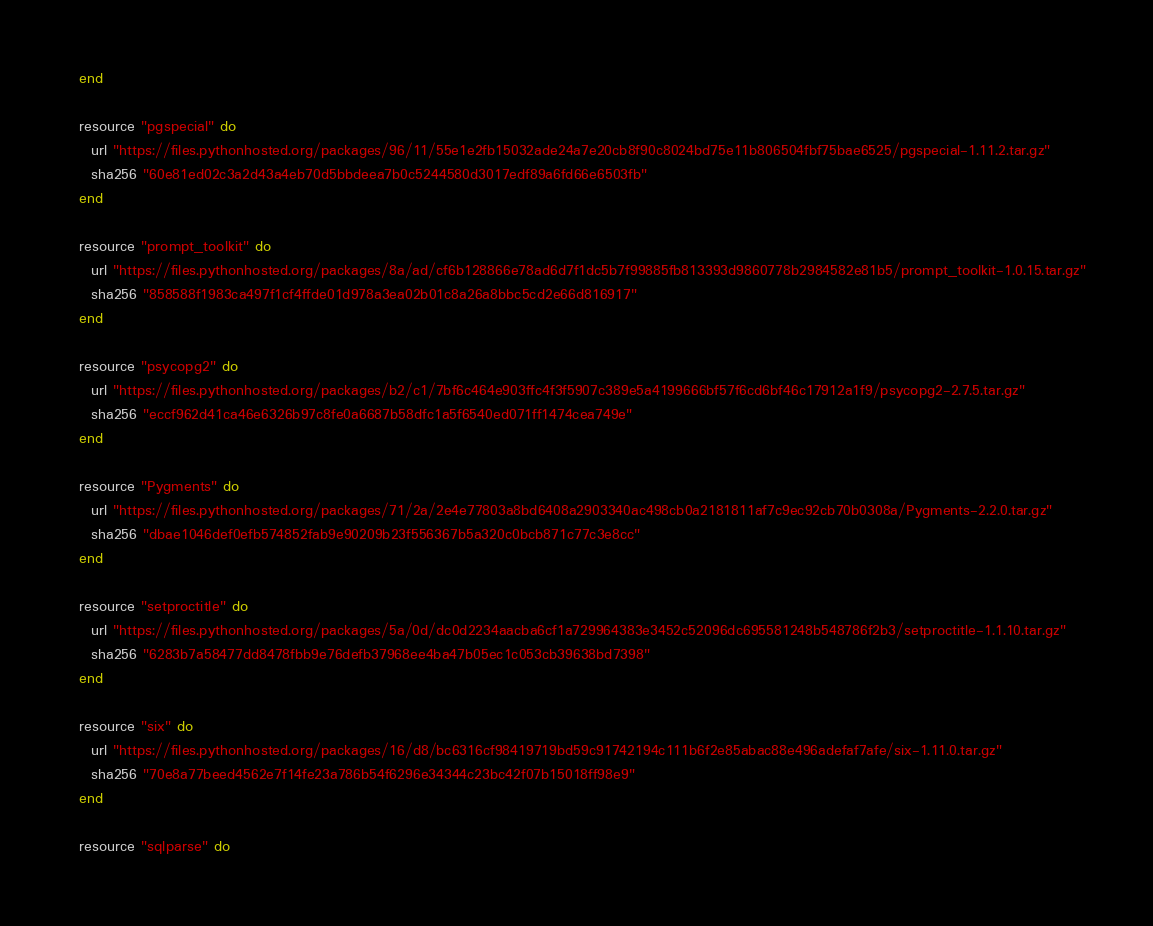<code> <loc_0><loc_0><loc_500><loc_500><_Ruby_>  end

  resource "pgspecial" do
    url "https://files.pythonhosted.org/packages/96/11/55e1e2fb15032ade24a7e20cb8f90c8024bd75e11b806504fbf75bae6525/pgspecial-1.11.2.tar.gz"
    sha256 "60e81ed02c3a2d43a4eb70d5bbdeea7b0c5244580d3017edf89a6fd66e6503fb"
  end

  resource "prompt_toolkit" do
    url "https://files.pythonhosted.org/packages/8a/ad/cf6b128866e78ad6d7f1dc5b7f99885fb813393d9860778b2984582e81b5/prompt_toolkit-1.0.15.tar.gz"
    sha256 "858588f1983ca497f1cf4ffde01d978a3ea02b01c8a26a8bbc5cd2e66d816917"
  end

  resource "psycopg2" do
    url "https://files.pythonhosted.org/packages/b2/c1/7bf6c464e903ffc4f3f5907c389e5a4199666bf57f6cd6bf46c17912a1f9/psycopg2-2.7.5.tar.gz"
    sha256 "eccf962d41ca46e6326b97c8fe0a6687b58dfc1a5f6540ed071ff1474cea749e"
  end

  resource "Pygments" do
    url "https://files.pythonhosted.org/packages/71/2a/2e4e77803a8bd6408a2903340ac498cb0a2181811af7c9ec92cb70b0308a/Pygments-2.2.0.tar.gz"
    sha256 "dbae1046def0efb574852fab9e90209b23f556367b5a320c0bcb871c77c3e8cc"
  end

  resource "setproctitle" do
    url "https://files.pythonhosted.org/packages/5a/0d/dc0d2234aacba6cf1a729964383e3452c52096dc695581248b548786f2b3/setproctitle-1.1.10.tar.gz"
    sha256 "6283b7a58477dd8478fbb9e76defb37968ee4ba47b05ec1c053cb39638bd7398"
  end

  resource "six" do
    url "https://files.pythonhosted.org/packages/16/d8/bc6316cf98419719bd59c91742194c111b6f2e85abac88e496adefaf7afe/six-1.11.0.tar.gz"
    sha256 "70e8a77beed4562e7f14fe23a786b54f6296e34344c23bc42f07b15018ff98e9"
  end

  resource "sqlparse" do</code> 